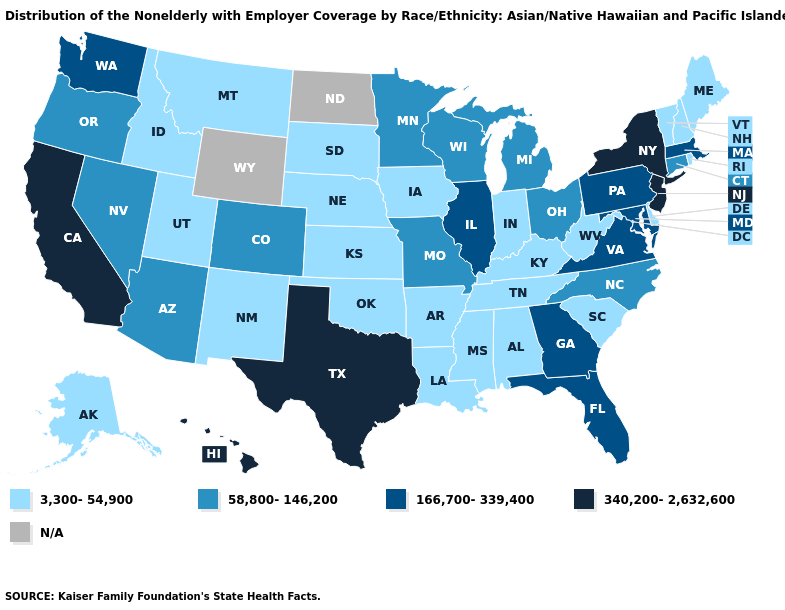Does Connecticut have the lowest value in the Northeast?
Write a very short answer. No. What is the value of Maryland?
Write a very short answer. 166,700-339,400. Which states have the lowest value in the USA?
Give a very brief answer. Alabama, Alaska, Arkansas, Delaware, Idaho, Indiana, Iowa, Kansas, Kentucky, Louisiana, Maine, Mississippi, Montana, Nebraska, New Hampshire, New Mexico, Oklahoma, Rhode Island, South Carolina, South Dakota, Tennessee, Utah, Vermont, West Virginia. What is the lowest value in states that border New Hampshire?
Quick response, please. 3,300-54,900. Which states have the lowest value in the USA?
Short answer required. Alabama, Alaska, Arkansas, Delaware, Idaho, Indiana, Iowa, Kansas, Kentucky, Louisiana, Maine, Mississippi, Montana, Nebraska, New Hampshire, New Mexico, Oklahoma, Rhode Island, South Carolina, South Dakota, Tennessee, Utah, Vermont, West Virginia. Is the legend a continuous bar?
Short answer required. No. What is the value of North Dakota?
Quick response, please. N/A. Does Georgia have the lowest value in the South?
Short answer required. No. Name the states that have a value in the range 58,800-146,200?
Concise answer only. Arizona, Colorado, Connecticut, Michigan, Minnesota, Missouri, Nevada, North Carolina, Ohio, Oregon, Wisconsin. What is the highest value in the USA?
Quick response, please. 340,200-2,632,600. Among the states that border Michigan , does Indiana have the lowest value?
Concise answer only. Yes. What is the value of Idaho?
Give a very brief answer. 3,300-54,900. Which states have the lowest value in the West?
Keep it brief. Alaska, Idaho, Montana, New Mexico, Utah. 